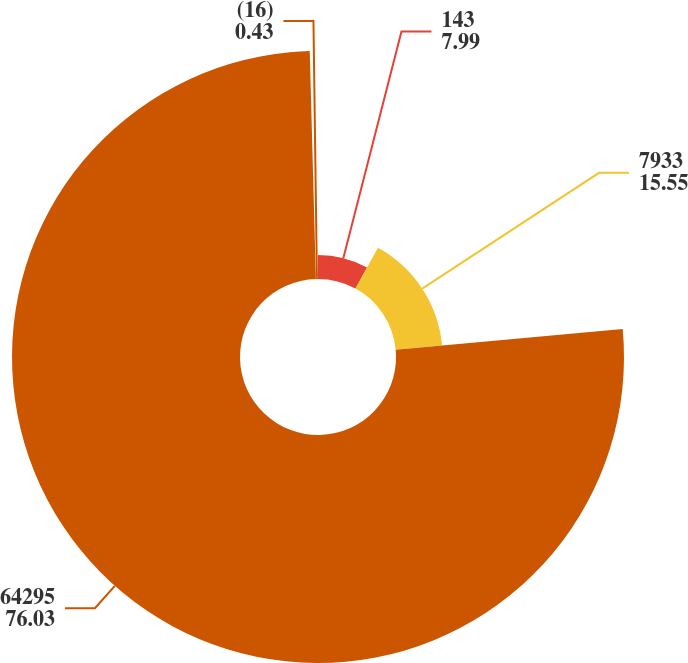<chart> <loc_0><loc_0><loc_500><loc_500><pie_chart><fcel>143<fcel>7933<fcel>64295<fcel>(16)<nl><fcel>7.99%<fcel>15.55%<fcel>76.03%<fcel>0.43%<nl></chart> 